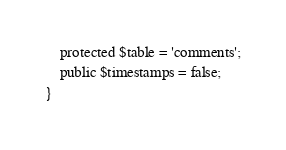Convert code to text. <code><loc_0><loc_0><loc_500><loc_500><_PHP_>    protected $table = 'comments';
    public $timestamps = false;
}
</code> 